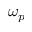<formula> <loc_0><loc_0><loc_500><loc_500>\omega _ { p }</formula> 